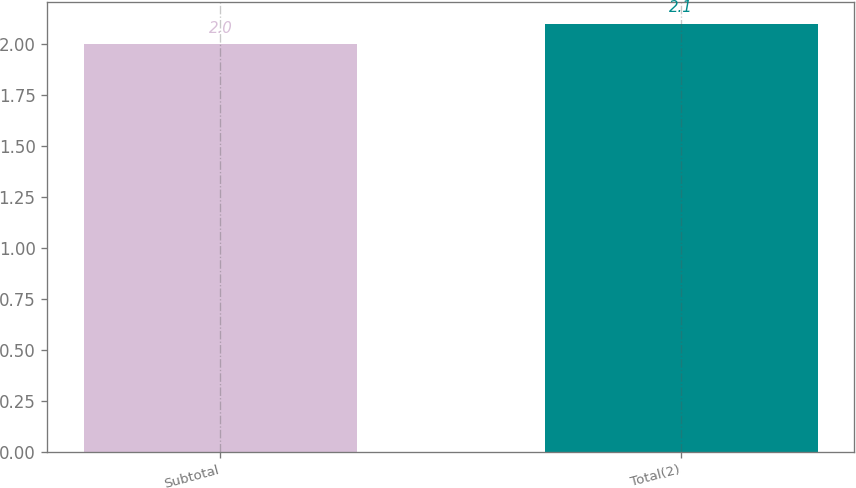Convert chart. <chart><loc_0><loc_0><loc_500><loc_500><bar_chart><fcel>Subtotal<fcel>Total(2)<nl><fcel>2<fcel>2.1<nl></chart> 